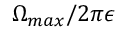Convert formula to latex. <formula><loc_0><loc_0><loc_500><loc_500>\Omega _ { \max } / 2 \pi \epsilon</formula> 